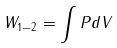Convert formula to latex. <formula><loc_0><loc_0><loc_500><loc_500>W _ { 1 - 2 } = \int P d V</formula> 